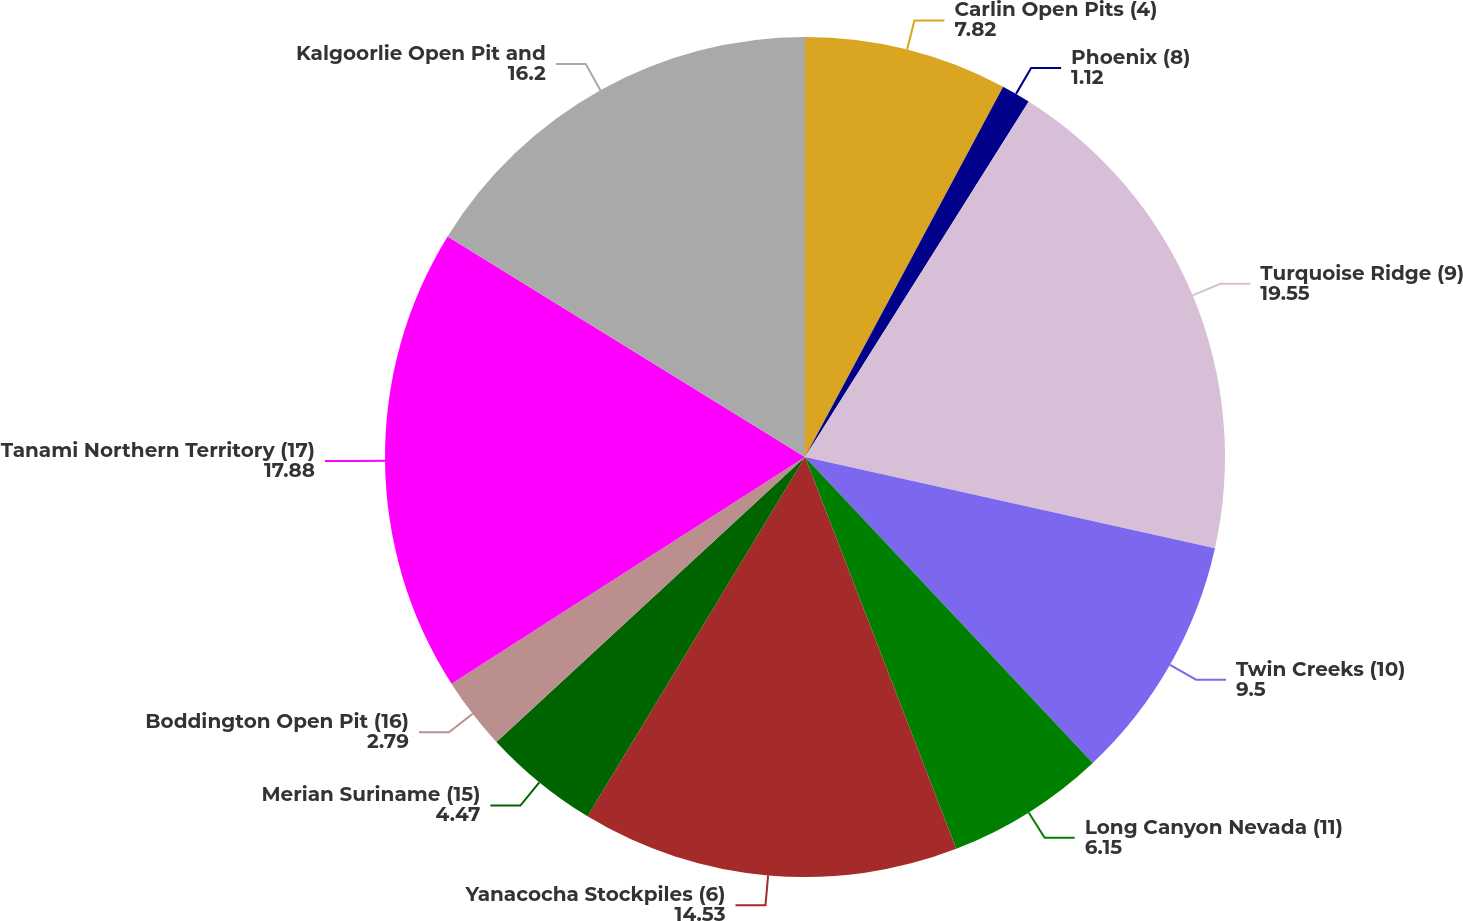Convert chart. <chart><loc_0><loc_0><loc_500><loc_500><pie_chart><fcel>Carlin Open Pits (4)<fcel>Phoenix (8)<fcel>Turquoise Ridge (9)<fcel>Twin Creeks (10)<fcel>Long Canyon Nevada (11)<fcel>Yanacocha Stockpiles (6)<fcel>Merian Suriname (15)<fcel>Boddington Open Pit (16)<fcel>Tanami Northern Territory (17)<fcel>Kalgoorlie Open Pit and<nl><fcel>7.82%<fcel>1.12%<fcel>19.55%<fcel>9.5%<fcel>6.15%<fcel>14.53%<fcel>4.47%<fcel>2.79%<fcel>17.88%<fcel>16.2%<nl></chart> 